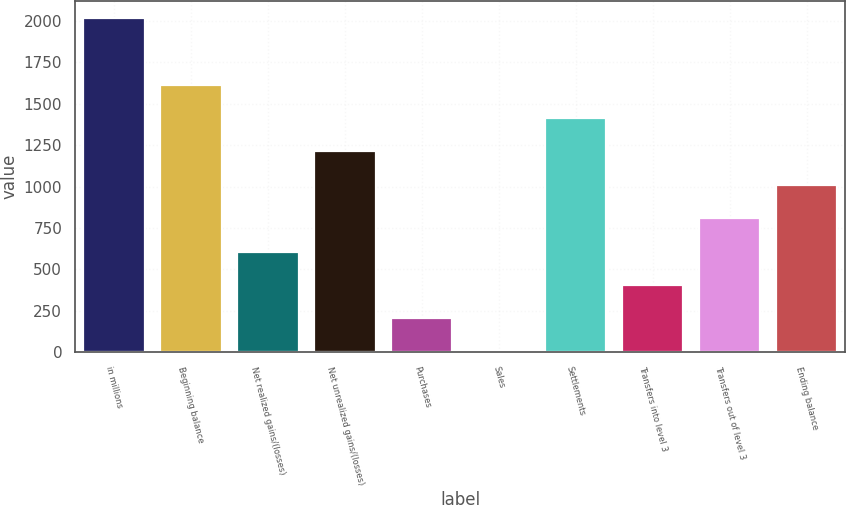Convert chart to OTSL. <chart><loc_0><loc_0><loc_500><loc_500><bar_chart><fcel>in millions<fcel>Beginning balance<fcel>Net realized gains/(losses)<fcel>Net unrealized gains/(losses)<fcel>Purchases<fcel>Sales<fcel>Settlements<fcel>Transfers into level 3<fcel>Transfers out of level 3<fcel>Ending balance<nl><fcel>2018<fcel>1614.8<fcel>606.8<fcel>1211.6<fcel>203.6<fcel>2<fcel>1413.2<fcel>405.2<fcel>808.4<fcel>1010<nl></chart> 